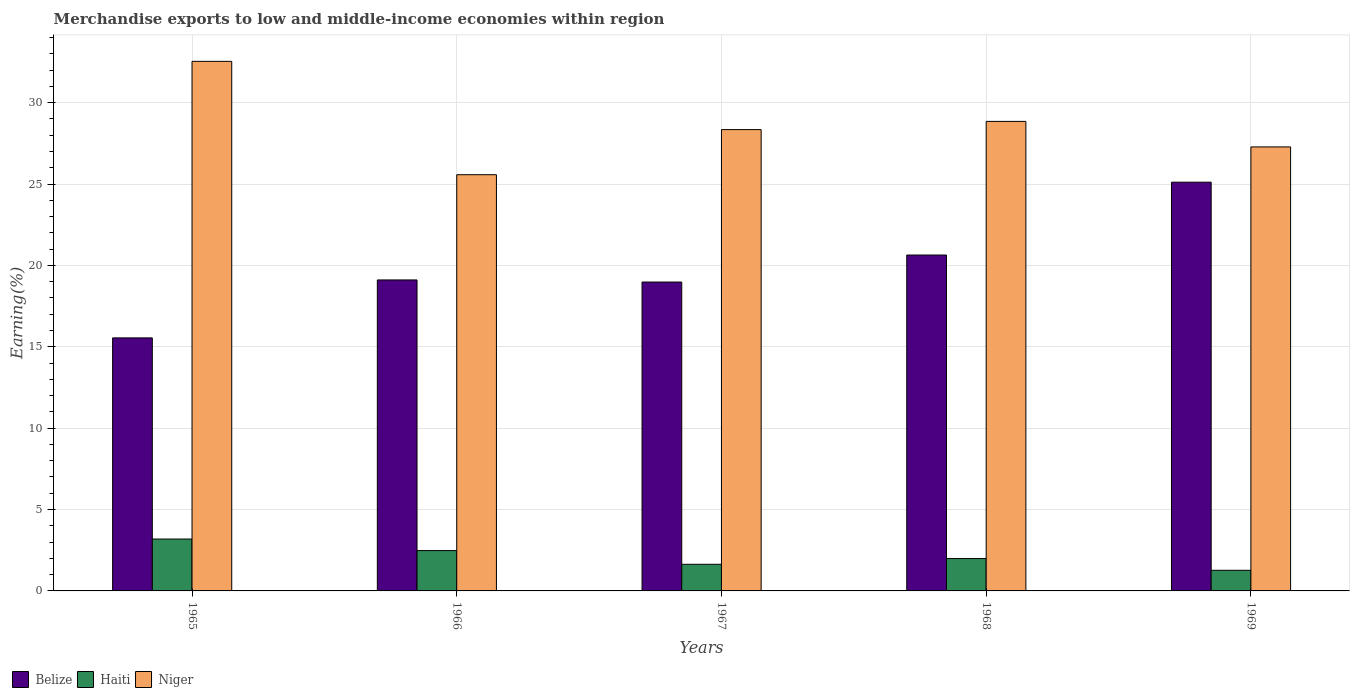How many groups of bars are there?
Make the answer very short. 5. How many bars are there on the 4th tick from the left?
Your answer should be compact. 3. What is the label of the 1st group of bars from the left?
Provide a short and direct response. 1965. What is the percentage of amount earned from merchandise exports in Haiti in 1965?
Ensure brevity in your answer.  3.19. Across all years, what is the maximum percentage of amount earned from merchandise exports in Niger?
Keep it short and to the point. 32.54. Across all years, what is the minimum percentage of amount earned from merchandise exports in Niger?
Offer a terse response. 25.57. In which year was the percentage of amount earned from merchandise exports in Belize maximum?
Give a very brief answer. 1969. In which year was the percentage of amount earned from merchandise exports in Niger minimum?
Offer a terse response. 1966. What is the total percentage of amount earned from merchandise exports in Haiti in the graph?
Your answer should be very brief. 10.56. What is the difference between the percentage of amount earned from merchandise exports in Niger in 1965 and that in 1966?
Provide a short and direct response. 6.96. What is the difference between the percentage of amount earned from merchandise exports in Belize in 1968 and the percentage of amount earned from merchandise exports in Haiti in 1969?
Provide a short and direct response. 19.37. What is the average percentage of amount earned from merchandise exports in Niger per year?
Give a very brief answer. 28.52. In the year 1968, what is the difference between the percentage of amount earned from merchandise exports in Niger and percentage of amount earned from merchandise exports in Belize?
Your answer should be very brief. 8.21. What is the ratio of the percentage of amount earned from merchandise exports in Belize in 1968 to that in 1969?
Your response must be concise. 0.82. Is the percentage of amount earned from merchandise exports in Haiti in 1967 less than that in 1969?
Your answer should be compact. No. Is the difference between the percentage of amount earned from merchandise exports in Niger in 1967 and 1968 greater than the difference between the percentage of amount earned from merchandise exports in Belize in 1967 and 1968?
Offer a very short reply. Yes. What is the difference between the highest and the second highest percentage of amount earned from merchandise exports in Belize?
Ensure brevity in your answer.  4.48. What is the difference between the highest and the lowest percentage of amount earned from merchandise exports in Belize?
Ensure brevity in your answer.  9.57. In how many years, is the percentage of amount earned from merchandise exports in Belize greater than the average percentage of amount earned from merchandise exports in Belize taken over all years?
Offer a terse response. 2. What does the 2nd bar from the left in 1968 represents?
Make the answer very short. Haiti. What does the 3rd bar from the right in 1966 represents?
Make the answer very short. Belize. Is it the case that in every year, the sum of the percentage of amount earned from merchandise exports in Haiti and percentage of amount earned from merchandise exports in Niger is greater than the percentage of amount earned from merchandise exports in Belize?
Your response must be concise. Yes. Are all the bars in the graph horizontal?
Make the answer very short. No. How many years are there in the graph?
Provide a succinct answer. 5. Are the values on the major ticks of Y-axis written in scientific E-notation?
Make the answer very short. No. Does the graph contain grids?
Provide a short and direct response. Yes. How are the legend labels stacked?
Offer a very short reply. Horizontal. What is the title of the graph?
Offer a terse response. Merchandise exports to low and middle-income economies within region. Does "Bosnia and Herzegovina" appear as one of the legend labels in the graph?
Your answer should be very brief. No. What is the label or title of the X-axis?
Provide a short and direct response. Years. What is the label or title of the Y-axis?
Offer a very short reply. Earning(%). What is the Earning(%) of Belize in 1965?
Ensure brevity in your answer.  15.55. What is the Earning(%) in Haiti in 1965?
Provide a short and direct response. 3.19. What is the Earning(%) of Niger in 1965?
Your response must be concise. 32.54. What is the Earning(%) in Belize in 1966?
Your answer should be very brief. 19.11. What is the Earning(%) of Haiti in 1966?
Ensure brevity in your answer.  2.48. What is the Earning(%) of Niger in 1966?
Provide a short and direct response. 25.57. What is the Earning(%) in Belize in 1967?
Your answer should be very brief. 18.98. What is the Earning(%) of Haiti in 1967?
Offer a very short reply. 1.64. What is the Earning(%) of Niger in 1967?
Your response must be concise. 28.35. What is the Earning(%) in Belize in 1968?
Give a very brief answer. 20.64. What is the Earning(%) in Haiti in 1968?
Your answer should be compact. 1.99. What is the Earning(%) in Niger in 1968?
Offer a terse response. 28.85. What is the Earning(%) in Belize in 1969?
Provide a short and direct response. 25.12. What is the Earning(%) in Haiti in 1969?
Provide a short and direct response. 1.27. What is the Earning(%) in Niger in 1969?
Offer a very short reply. 27.28. Across all years, what is the maximum Earning(%) of Belize?
Your answer should be compact. 25.12. Across all years, what is the maximum Earning(%) in Haiti?
Your answer should be very brief. 3.19. Across all years, what is the maximum Earning(%) in Niger?
Provide a short and direct response. 32.54. Across all years, what is the minimum Earning(%) of Belize?
Your answer should be very brief. 15.55. Across all years, what is the minimum Earning(%) of Haiti?
Your answer should be compact. 1.27. Across all years, what is the minimum Earning(%) in Niger?
Give a very brief answer. 25.57. What is the total Earning(%) in Belize in the graph?
Make the answer very short. 99.39. What is the total Earning(%) of Haiti in the graph?
Offer a terse response. 10.56. What is the total Earning(%) in Niger in the graph?
Make the answer very short. 142.59. What is the difference between the Earning(%) of Belize in 1965 and that in 1966?
Provide a short and direct response. -3.56. What is the difference between the Earning(%) in Haiti in 1965 and that in 1966?
Ensure brevity in your answer.  0.71. What is the difference between the Earning(%) in Niger in 1965 and that in 1966?
Keep it short and to the point. 6.96. What is the difference between the Earning(%) in Belize in 1965 and that in 1967?
Your response must be concise. -3.43. What is the difference between the Earning(%) in Haiti in 1965 and that in 1967?
Make the answer very short. 1.55. What is the difference between the Earning(%) in Niger in 1965 and that in 1967?
Your answer should be very brief. 4.19. What is the difference between the Earning(%) in Belize in 1965 and that in 1968?
Provide a short and direct response. -5.09. What is the difference between the Earning(%) in Haiti in 1965 and that in 1968?
Make the answer very short. 1.2. What is the difference between the Earning(%) of Niger in 1965 and that in 1968?
Your answer should be very brief. 3.69. What is the difference between the Earning(%) in Belize in 1965 and that in 1969?
Give a very brief answer. -9.57. What is the difference between the Earning(%) of Haiti in 1965 and that in 1969?
Offer a terse response. 1.92. What is the difference between the Earning(%) of Niger in 1965 and that in 1969?
Your answer should be very brief. 5.26. What is the difference between the Earning(%) in Belize in 1966 and that in 1967?
Make the answer very short. 0.13. What is the difference between the Earning(%) of Haiti in 1966 and that in 1967?
Give a very brief answer. 0.84. What is the difference between the Earning(%) in Niger in 1966 and that in 1967?
Provide a short and direct response. -2.77. What is the difference between the Earning(%) in Belize in 1966 and that in 1968?
Ensure brevity in your answer.  -1.53. What is the difference between the Earning(%) of Haiti in 1966 and that in 1968?
Your response must be concise. 0.49. What is the difference between the Earning(%) of Niger in 1966 and that in 1968?
Provide a short and direct response. -3.28. What is the difference between the Earning(%) in Belize in 1966 and that in 1969?
Provide a succinct answer. -6.01. What is the difference between the Earning(%) of Haiti in 1966 and that in 1969?
Your answer should be compact. 1.21. What is the difference between the Earning(%) in Niger in 1966 and that in 1969?
Your response must be concise. -1.71. What is the difference between the Earning(%) of Belize in 1967 and that in 1968?
Your response must be concise. -1.66. What is the difference between the Earning(%) in Haiti in 1967 and that in 1968?
Offer a terse response. -0.35. What is the difference between the Earning(%) of Niger in 1967 and that in 1968?
Provide a short and direct response. -0.5. What is the difference between the Earning(%) of Belize in 1967 and that in 1969?
Make the answer very short. -6.14. What is the difference between the Earning(%) in Haiti in 1967 and that in 1969?
Your answer should be very brief. 0.37. What is the difference between the Earning(%) of Niger in 1967 and that in 1969?
Provide a short and direct response. 1.06. What is the difference between the Earning(%) of Belize in 1968 and that in 1969?
Your response must be concise. -4.48. What is the difference between the Earning(%) of Haiti in 1968 and that in 1969?
Provide a short and direct response. 0.72. What is the difference between the Earning(%) in Niger in 1968 and that in 1969?
Give a very brief answer. 1.57. What is the difference between the Earning(%) in Belize in 1965 and the Earning(%) in Haiti in 1966?
Your answer should be compact. 13.07. What is the difference between the Earning(%) in Belize in 1965 and the Earning(%) in Niger in 1966?
Give a very brief answer. -10.03. What is the difference between the Earning(%) of Haiti in 1965 and the Earning(%) of Niger in 1966?
Your response must be concise. -22.39. What is the difference between the Earning(%) in Belize in 1965 and the Earning(%) in Haiti in 1967?
Provide a short and direct response. 13.91. What is the difference between the Earning(%) of Belize in 1965 and the Earning(%) of Niger in 1967?
Make the answer very short. -12.8. What is the difference between the Earning(%) of Haiti in 1965 and the Earning(%) of Niger in 1967?
Provide a succinct answer. -25.16. What is the difference between the Earning(%) of Belize in 1965 and the Earning(%) of Haiti in 1968?
Make the answer very short. 13.56. What is the difference between the Earning(%) of Belize in 1965 and the Earning(%) of Niger in 1968?
Your answer should be compact. -13.3. What is the difference between the Earning(%) of Haiti in 1965 and the Earning(%) of Niger in 1968?
Your response must be concise. -25.66. What is the difference between the Earning(%) in Belize in 1965 and the Earning(%) in Haiti in 1969?
Provide a short and direct response. 14.28. What is the difference between the Earning(%) of Belize in 1965 and the Earning(%) of Niger in 1969?
Your answer should be compact. -11.73. What is the difference between the Earning(%) of Haiti in 1965 and the Earning(%) of Niger in 1969?
Offer a terse response. -24.09. What is the difference between the Earning(%) in Belize in 1966 and the Earning(%) in Haiti in 1967?
Keep it short and to the point. 17.47. What is the difference between the Earning(%) in Belize in 1966 and the Earning(%) in Niger in 1967?
Provide a succinct answer. -9.24. What is the difference between the Earning(%) in Haiti in 1966 and the Earning(%) in Niger in 1967?
Offer a very short reply. -25.87. What is the difference between the Earning(%) of Belize in 1966 and the Earning(%) of Haiti in 1968?
Your answer should be compact. 17.12. What is the difference between the Earning(%) in Belize in 1966 and the Earning(%) in Niger in 1968?
Offer a very short reply. -9.74. What is the difference between the Earning(%) in Haiti in 1966 and the Earning(%) in Niger in 1968?
Give a very brief answer. -26.37. What is the difference between the Earning(%) in Belize in 1966 and the Earning(%) in Haiti in 1969?
Keep it short and to the point. 17.84. What is the difference between the Earning(%) in Belize in 1966 and the Earning(%) in Niger in 1969?
Provide a short and direct response. -8.17. What is the difference between the Earning(%) in Haiti in 1966 and the Earning(%) in Niger in 1969?
Ensure brevity in your answer.  -24.8. What is the difference between the Earning(%) in Belize in 1967 and the Earning(%) in Haiti in 1968?
Offer a very short reply. 16.99. What is the difference between the Earning(%) in Belize in 1967 and the Earning(%) in Niger in 1968?
Provide a succinct answer. -9.87. What is the difference between the Earning(%) of Haiti in 1967 and the Earning(%) of Niger in 1968?
Offer a terse response. -27.21. What is the difference between the Earning(%) of Belize in 1967 and the Earning(%) of Haiti in 1969?
Your answer should be very brief. 17.71. What is the difference between the Earning(%) in Belize in 1967 and the Earning(%) in Niger in 1969?
Offer a very short reply. -8.3. What is the difference between the Earning(%) in Haiti in 1967 and the Earning(%) in Niger in 1969?
Make the answer very short. -25.65. What is the difference between the Earning(%) in Belize in 1968 and the Earning(%) in Haiti in 1969?
Keep it short and to the point. 19.37. What is the difference between the Earning(%) in Belize in 1968 and the Earning(%) in Niger in 1969?
Make the answer very short. -6.64. What is the difference between the Earning(%) in Haiti in 1968 and the Earning(%) in Niger in 1969?
Offer a very short reply. -25.29. What is the average Earning(%) in Belize per year?
Your response must be concise. 19.88. What is the average Earning(%) of Haiti per year?
Give a very brief answer. 2.11. What is the average Earning(%) in Niger per year?
Make the answer very short. 28.52. In the year 1965, what is the difference between the Earning(%) in Belize and Earning(%) in Haiti?
Ensure brevity in your answer.  12.36. In the year 1965, what is the difference between the Earning(%) in Belize and Earning(%) in Niger?
Your answer should be very brief. -16.99. In the year 1965, what is the difference between the Earning(%) of Haiti and Earning(%) of Niger?
Provide a short and direct response. -29.35. In the year 1966, what is the difference between the Earning(%) in Belize and Earning(%) in Haiti?
Ensure brevity in your answer.  16.63. In the year 1966, what is the difference between the Earning(%) of Belize and Earning(%) of Niger?
Your response must be concise. -6.47. In the year 1966, what is the difference between the Earning(%) of Haiti and Earning(%) of Niger?
Offer a terse response. -23.1. In the year 1967, what is the difference between the Earning(%) in Belize and Earning(%) in Haiti?
Ensure brevity in your answer.  17.34. In the year 1967, what is the difference between the Earning(%) of Belize and Earning(%) of Niger?
Ensure brevity in your answer.  -9.37. In the year 1967, what is the difference between the Earning(%) in Haiti and Earning(%) in Niger?
Offer a terse response. -26.71. In the year 1968, what is the difference between the Earning(%) of Belize and Earning(%) of Haiti?
Keep it short and to the point. 18.65. In the year 1968, what is the difference between the Earning(%) in Belize and Earning(%) in Niger?
Your answer should be very brief. -8.21. In the year 1968, what is the difference between the Earning(%) of Haiti and Earning(%) of Niger?
Provide a succinct answer. -26.86. In the year 1969, what is the difference between the Earning(%) in Belize and Earning(%) in Haiti?
Give a very brief answer. 23.85. In the year 1969, what is the difference between the Earning(%) of Belize and Earning(%) of Niger?
Keep it short and to the point. -2.17. In the year 1969, what is the difference between the Earning(%) of Haiti and Earning(%) of Niger?
Make the answer very short. -26.01. What is the ratio of the Earning(%) of Belize in 1965 to that in 1966?
Make the answer very short. 0.81. What is the ratio of the Earning(%) of Haiti in 1965 to that in 1966?
Keep it short and to the point. 1.29. What is the ratio of the Earning(%) of Niger in 1965 to that in 1966?
Provide a succinct answer. 1.27. What is the ratio of the Earning(%) of Belize in 1965 to that in 1967?
Your response must be concise. 0.82. What is the ratio of the Earning(%) in Haiti in 1965 to that in 1967?
Give a very brief answer. 1.95. What is the ratio of the Earning(%) of Niger in 1965 to that in 1967?
Offer a terse response. 1.15. What is the ratio of the Earning(%) of Belize in 1965 to that in 1968?
Your response must be concise. 0.75. What is the ratio of the Earning(%) of Haiti in 1965 to that in 1968?
Provide a succinct answer. 1.6. What is the ratio of the Earning(%) in Niger in 1965 to that in 1968?
Give a very brief answer. 1.13. What is the ratio of the Earning(%) in Belize in 1965 to that in 1969?
Keep it short and to the point. 0.62. What is the ratio of the Earning(%) of Haiti in 1965 to that in 1969?
Offer a very short reply. 2.51. What is the ratio of the Earning(%) in Niger in 1965 to that in 1969?
Offer a terse response. 1.19. What is the ratio of the Earning(%) of Belize in 1966 to that in 1967?
Give a very brief answer. 1.01. What is the ratio of the Earning(%) in Haiti in 1966 to that in 1967?
Your response must be concise. 1.52. What is the ratio of the Earning(%) in Niger in 1966 to that in 1967?
Ensure brevity in your answer.  0.9. What is the ratio of the Earning(%) in Belize in 1966 to that in 1968?
Make the answer very short. 0.93. What is the ratio of the Earning(%) of Haiti in 1966 to that in 1968?
Ensure brevity in your answer.  1.25. What is the ratio of the Earning(%) in Niger in 1966 to that in 1968?
Provide a succinct answer. 0.89. What is the ratio of the Earning(%) of Belize in 1966 to that in 1969?
Your response must be concise. 0.76. What is the ratio of the Earning(%) of Haiti in 1966 to that in 1969?
Give a very brief answer. 1.96. What is the ratio of the Earning(%) of Niger in 1966 to that in 1969?
Your response must be concise. 0.94. What is the ratio of the Earning(%) of Belize in 1967 to that in 1968?
Provide a short and direct response. 0.92. What is the ratio of the Earning(%) in Haiti in 1967 to that in 1968?
Make the answer very short. 0.82. What is the ratio of the Earning(%) in Niger in 1967 to that in 1968?
Provide a short and direct response. 0.98. What is the ratio of the Earning(%) in Belize in 1967 to that in 1969?
Your response must be concise. 0.76. What is the ratio of the Earning(%) of Haiti in 1967 to that in 1969?
Offer a terse response. 1.29. What is the ratio of the Earning(%) in Niger in 1967 to that in 1969?
Make the answer very short. 1.04. What is the ratio of the Earning(%) in Belize in 1968 to that in 1969?
Keep it short and to the point. 0.82. What is the ratio of the Earning(%) in Haiti in 1968 to that in 1969?
Your response must be concise. 1.57. What is the ratio of the Earning(%) of Niger in 1968 to that in 1969?
Keep it short and to the point. 1.06. What is the difference between the highest and the second highest Earning(%) in Belize?
Make the answer very short. 4.48. What is the difference between the highest and the second highest Earning(%) in Haiti?
Your response must be concise. 0.71. What is the difference between the highest and the second highest Earning(%) in Niger?
Ensure brevity in your answer.  3.69. What is the difference between the highest and the lowest Earning(%) in Belize?
Ensure brevity in your answer.  9.57. What is the difference between the highest and the lowest Earning(%) in Haiti?
Offer a terse response. 1.92. What is the difference between the highest and the lowest Earning(%) in Niger?
Keep it short and to the point. 6.96. 